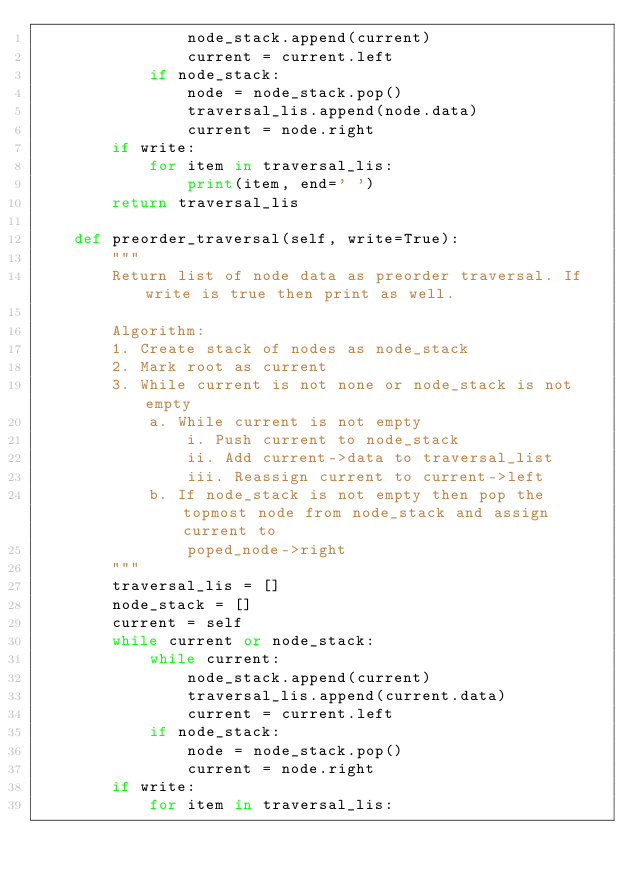Convert code to text. <code><loc_0><loc_0><loc_500><loc_500><_Python_>                node_stack.append(current)
                current = current.left
            if node_stack:
                node = node_stack.pop()
                traversal_lis.append(node.data)
                current = node.right
        if write:
            for item in traversal_lis:
                print(item, end=' ')
        return traversal_lis

    def preorder_traversal(self, write=True):
        """
        Return list of node data as preorder traversal. If write is true then print as well.

        Algorithm:
        1. Create stack of nodes as node_stack
        2. Mark root as current
        3. While current is not none or node_stack is not empty
            a. While current is not empty
                i. Push current to node_stack
                ii. Add current->data to traversal_list
                iii. Reassign current to current->left
            b. If node_stack is not empty then pop the topmost node from node_stack and assign current to
                poped_node->right
        """
        traversal_lis = []
        node_stack = []
        current = self
        while current or node_stack:
            while current:
                node_stack.append(current)
                traversal_lis.append(current.data)
                current = current.left
            if node_stack:
                node = node_stack.pop()
                current = node.right
        if write:
            for item in traversal_lis:</code> 